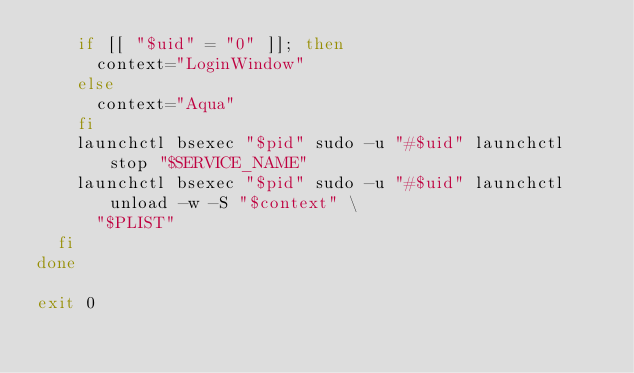Convert code to text. <code><loc_0><loc_0><loc_500><loc_500><_Bash_>    if [[ "$uid" = "0" ]]; then
      context="LoginWindow"
    else
      context="Aqua"
    fi
    launchctl bsexec "$pid" sudo -u "#$uid" launchctl stop "$SERVICE_NAME"
    launchctl bsexec "$pid" sudo -u "#$uid" launchctl unload -w -S "$context" \
      "$PLIST"
  fi
done

exit 0
</code> 